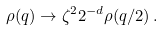Convert formula to latex. <formula><loc_0><loc_0><loc_500><loc_500>\rho ( q ) \rightarrow \zeta ^ { 2 } 2 ^ { - d } \rho ( q / 2 ) \, .</formula> 